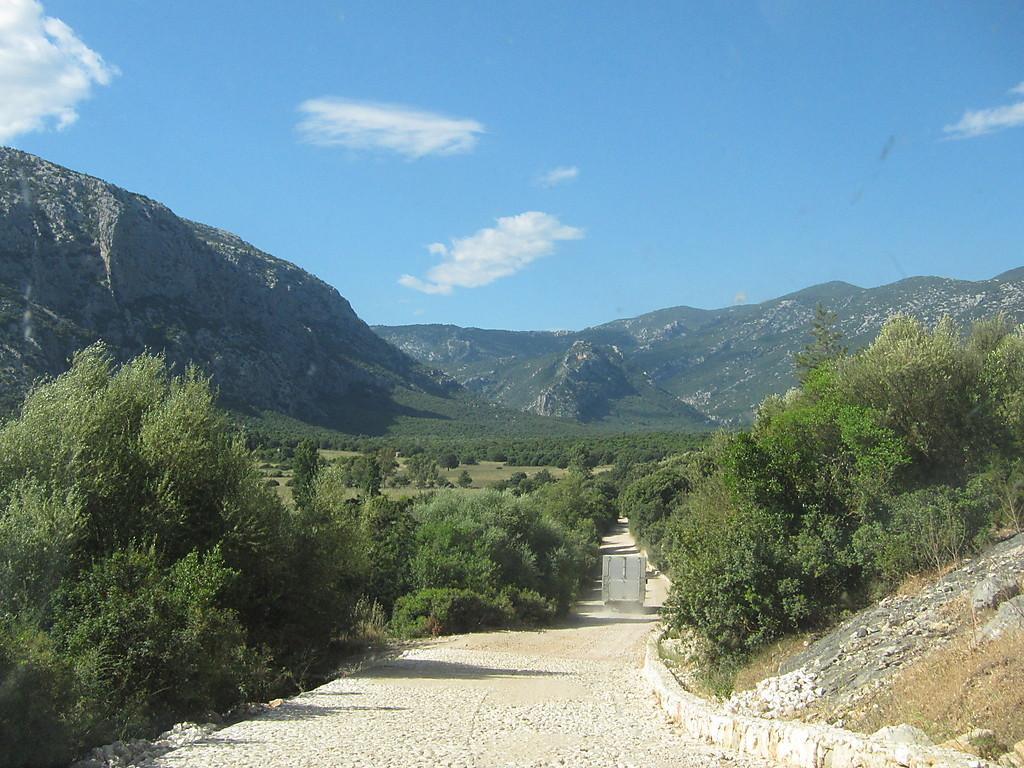Can you describe this image briefly? In this picture I can see trees, road on which I can see a vehicle. In the background I can see mountain and sky. 